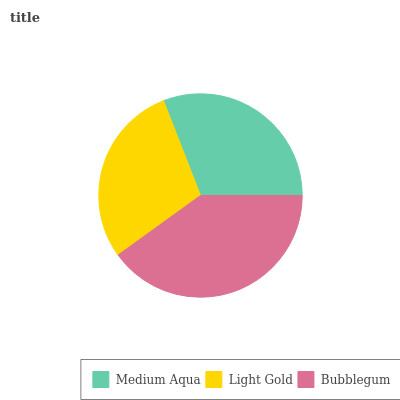Is Light Gold the minimum?
Answer yes or no. Yes. Is Bubblegum the maximum?
Answer yes or no. Yes. Is Bubblegum the minimum?
Answer yes or no. No. Is Light Gold the maximum?
Answer yes or no. No. Is Bubblegum greater than Light Gold?
Answer yes or no. Yes. Is Light Gold less than Bubblegum?
Answer yes or no. Yes. Is Light Gold greater than Bubblegum?
Answer yes or no. No. Is Bubblegum less than Light Gold?
Answer yes or no. No. Is Medium Aqua the high median?
Answer yes or no. Yes. Is Medium Aqua the low median?
Answer yes or no. Yes. Is Light Gold the high median?
Answer yes or no. No. Is Bubblegum the low median?
Answer yes or no. No. 